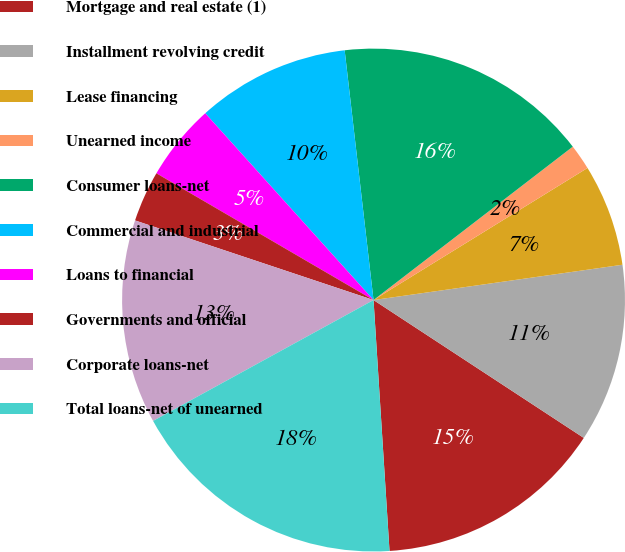<chart> <loc_0><loc_0><loc_500><loc_500><pie_chart><fcel>Mortgage and real estate (1)<fcel>Installment revolving credit<fcel>Lease financing<fcel>Unearned income<fcel>Consumer loans-net<fcel>Commercial and industrial<fcel>Loans to financial<fcel>Governments and official<fcel>Corporate loans-net<fcel>Total loans-net of unearned<nl><fcel>14.75%<fcel>11.48%<fcel>6.56%<fcel>1.64%<fcel>16.39%<fcel>9.84%<fcel>4.92%<fcel>3.28%<fcel>13.11%<fcel>18.03%<nl></chart> 